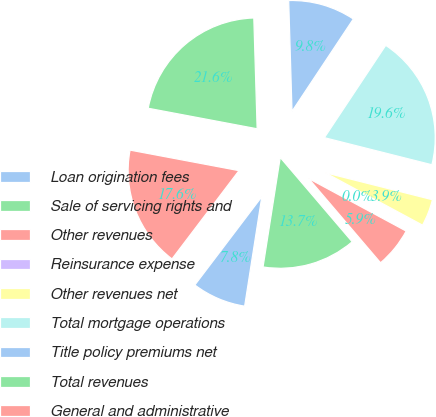Convert chart. <chart><loc_0><loc_0><loc_500><loc_500><pie_chart><fcel>Loan origination fees<fcel>Sale of servicing rights and<fcel>Other revenues<fcel>Reinsurance expense<fcel>Other revenues net<fcel>Total mortgage operations<fcel>Title policy premiums net<fcel>Total revenues<fcel>General and administrative<nl><fcel>7.85%<fcel>13.72%<fcel>5.89%<fcel>0.01%<fcel>3.93%<fcel>19.6%<fcel>9.81%<fcel>21.56%<fcel>17.64%<nl></chart> 